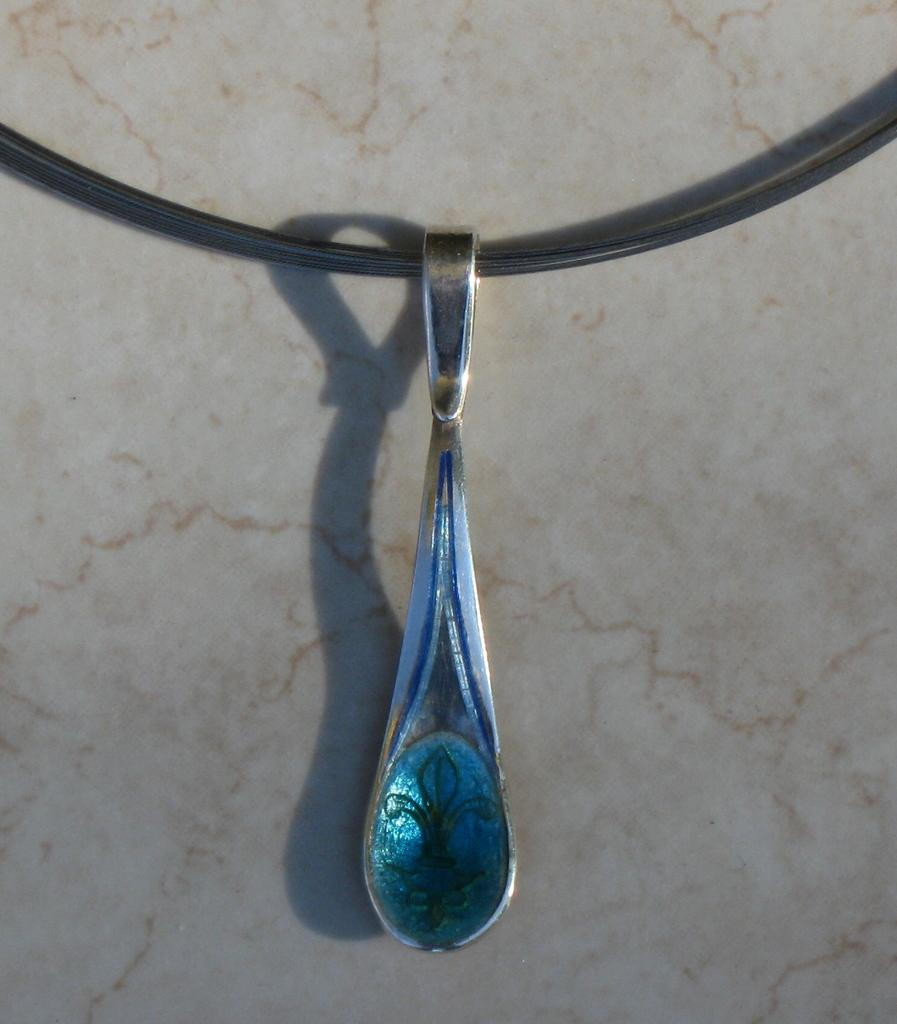What is the main object in the image? There is a locket in the image. How is the locket attached to something else? The locket is attached to a black thread. What color is the background of the image? The background of the image is cream-colored. How many apples are placed on the locket in the image? There are no apples present in the image; it only features a locket attached to a black thread against a cream-colored background. 